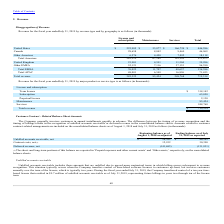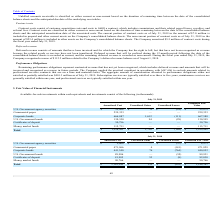According to Guidewire Software's financial document, What does the unbilled accounts receivables include? includes those amounts that are unbilled due to agreed-upon contractual terms in which billing occurs subsequent to revenue recognition.. The document states: "Unbilled accounts receivable includes those amounts that are unbilled due to agreed-upon contractual terms in which billing occurs subsequent to reven..." Also, What was the amount of unbilled accounts receivables in 2019 post transfer of control? According to the financial document, $9.7 million. The relevant text states: "of a ten year time- based license that resulted in $9.7 million of unbilled accounts receivable as of July 31, 2019, representing future billings in years two throu..." Also, What was the Contract costs, net in 2018 and 2019 respectively? The document shows two values: 12,932 and 30,390 (in thousands). From the document: "Contract costs, net (1) 12,932 30,390 Contract costs, net (1) 12,932 30,390..." Also, can you calculate: What was the change in the Unbilled accounts receivable, net from 2018 to 2019? Based on the calculation: 28,762 - 46,103, the result is -17341 (in thousands). This is based on the information: "Unbilled accounts receivable, net $ 28,762 $ 46,103 Unbilled accounts receivable, net $ 28,762 $ 46,103..." The key data points involved are: 28,762, 46,103. Also, can you calculate: What was the average Contract costs, net for 2018 and 2019? To answer this question, I need to perform calculations using the financial data. The calculation is: (12,932 + 30,390) / 2, which equals 21661 (in thousands). This is based on the information: "Contract costs, net (1) 12,932 30,390 Contract costs, net (1) 12,932 30,390..." The key data points involved are: 12,932, 30,390. Additionally, In which year was Contract costs, net less than 20,000 thousands? According to the financial document, 2018. The relevant text states: "n the consolidated balance sheets as of August 1, 2018 and July 31, 2019 as follows (in thousands):..." 